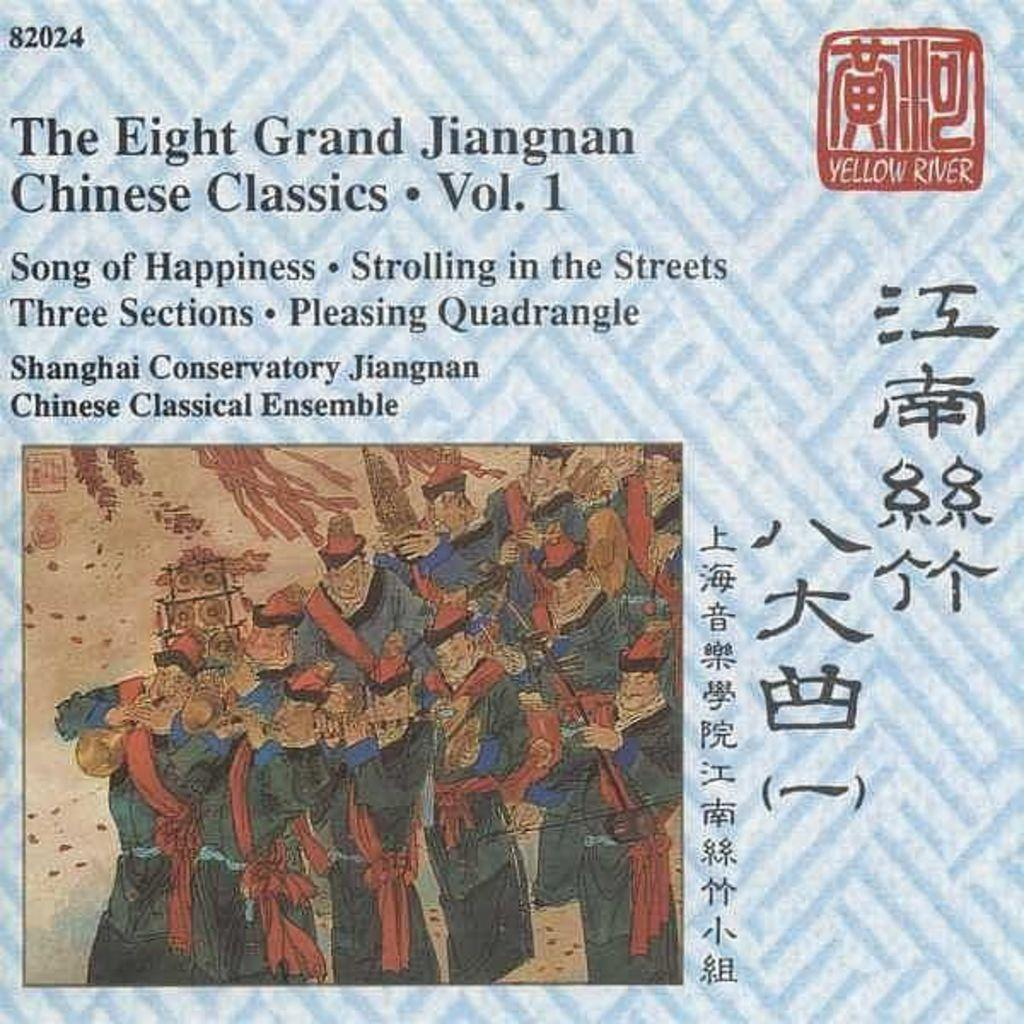What is present on the poster in the image? The poster contains text and an image. Can you describe the image on the poster? Unfortunately, the specific image on the poster cannot be described without more information. What type of content is conveyed through the text on the poster? The content of the text on the poster cannot be determined without more information. How many cobwebs can be seen on the poster in the image? There are no cobwebs present on the poster in the image. What time of day is depicted in the image, considering the presence of a giraffe? There is no giraffe present in the image, and therefore no indication of the time of day. 